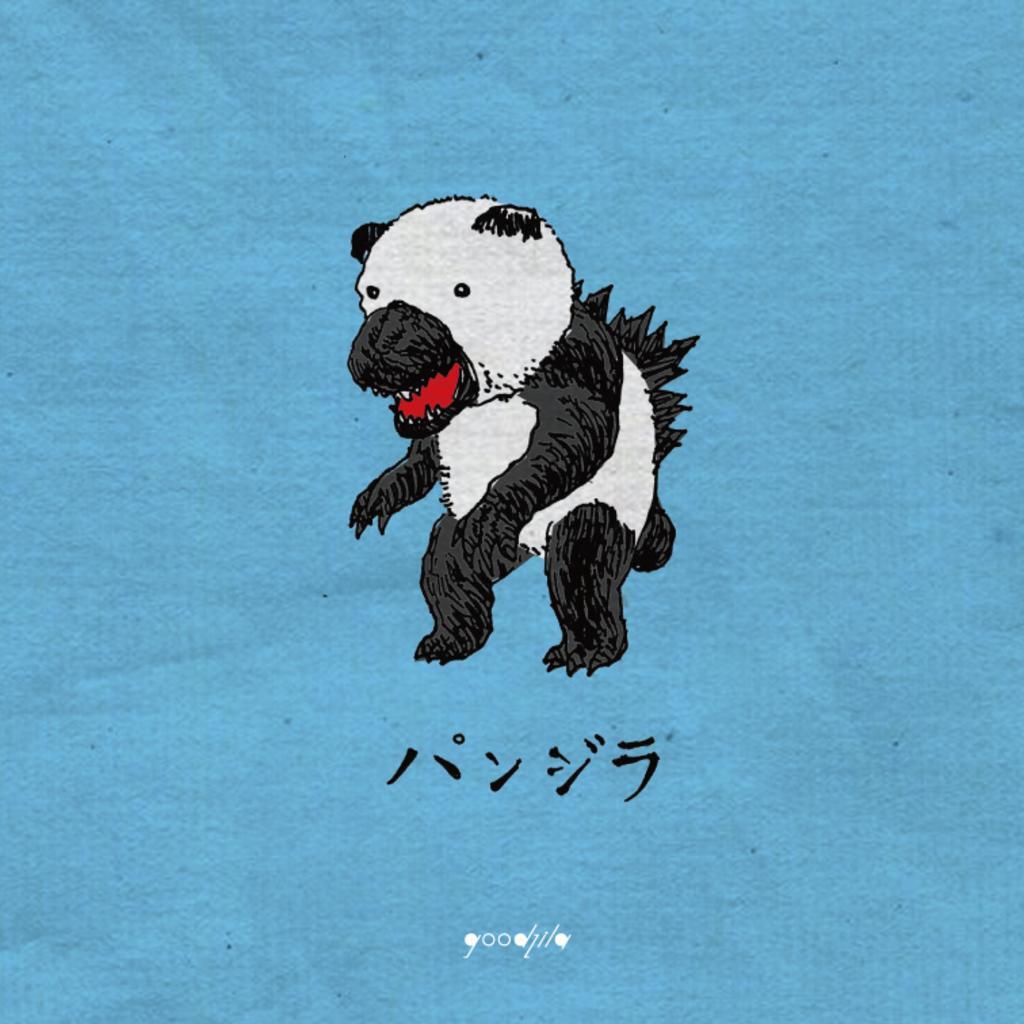Describe this image in one or two sentences. In this picture we can see a painting of an animal on the blue surface. 